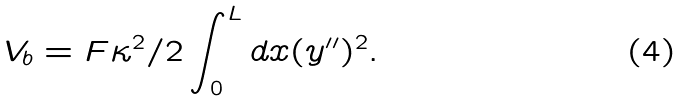Convert formula to latex. <formula><loc_0><loc_0><loc_500><loc_500>V _ { b } = F \kappa ^ { 2 } / { 2 } \int _ { 0 } ^ { L } d x ( y ^ { \prime \prime } ) ^ { 2 } .</formula> 